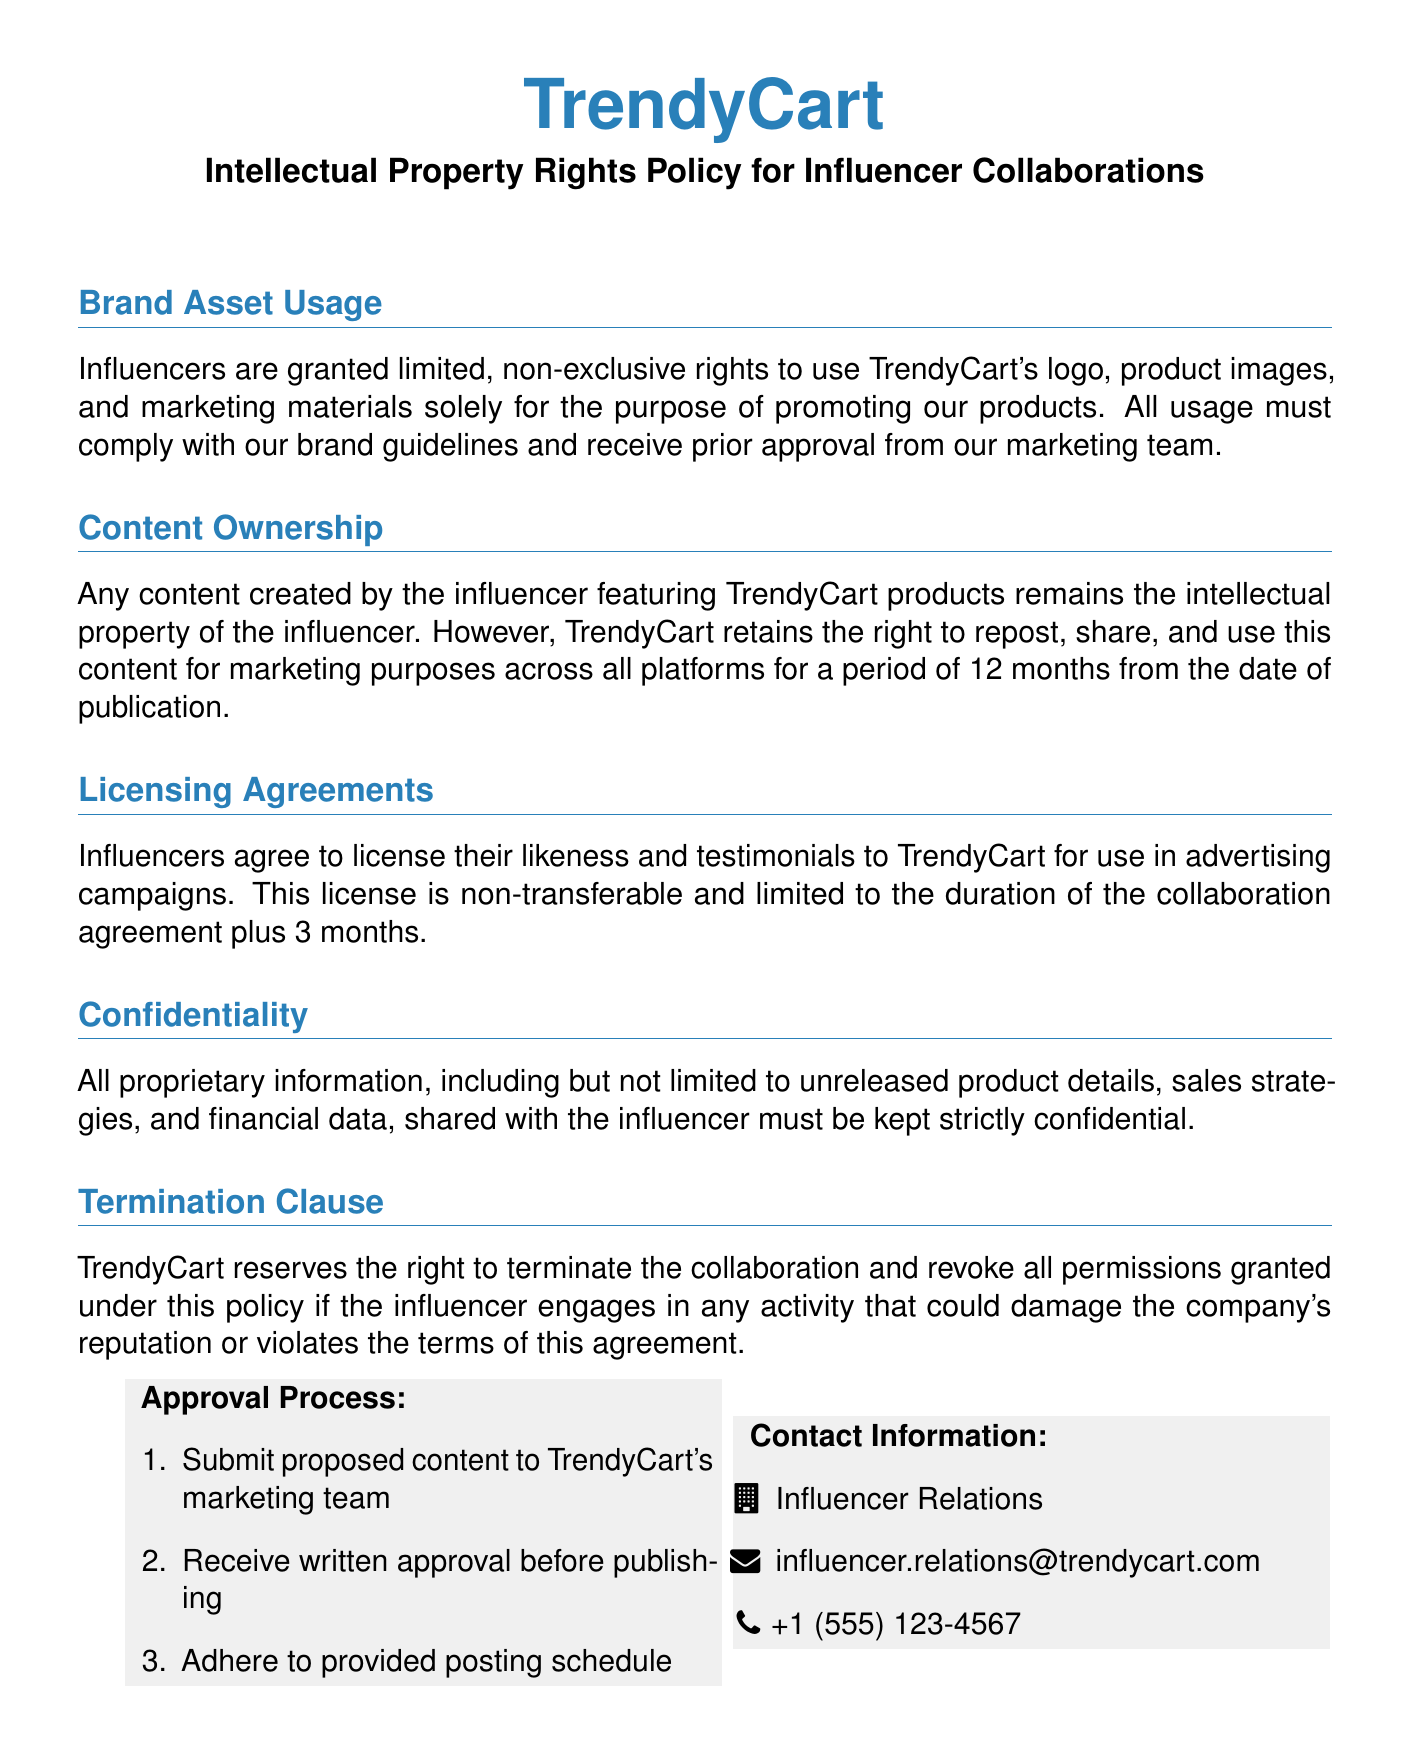What are influencers granted rights to use? Influencers are granted limited, non-exclusive rights to use TrendyCart's logo, product images, and marketing materials.
Answer: TrendyCart's logo, product images, and marketing materials How long does TrendyCart retain the right to repost influencer content? TrendyCart retains the right to repost and use this content for marketing purposes for a period of 12 months from the date of publication.
Answer: 12 months What must influencers do before using brand assets? Influencers must receive prior approval from the marketing team before using brand assets.
Answer: Receive prior approval What is the duration of the licensing agreement for the influencer's likeness? The licensing agreement for the influencer's likeness is limited to the duration of the collaboration agreement plus 3 months.
Answer: Duration of the collaboration agreement plus 3 months Who should influencers contact for questions regarding the policy? Influencers should contact the Influencer Relations department for questions regarding the policy.
Answer: Influencer Relations What information must be kept confidential by the influencer? All proprietary information, including unreleased product details, sales strategies, and financial data, must be kept confidential.
Answer: Proprietary information What is the first step in the approval process for proposed content? The first step in the approval process is to submit proposed content to TrendyCart's marketing team.
Answer: Submit proposed content What happens if the influencer damages the company's reputation? TrendyCart reserves the right to terminate the collaboration and revoke all permissions granted under this policy.
Answer: Terminate the collaboration What color is used for headings in the policy document? The color used for headings in the policy document is trendycartblue.
Answer: TrendyCart blue 